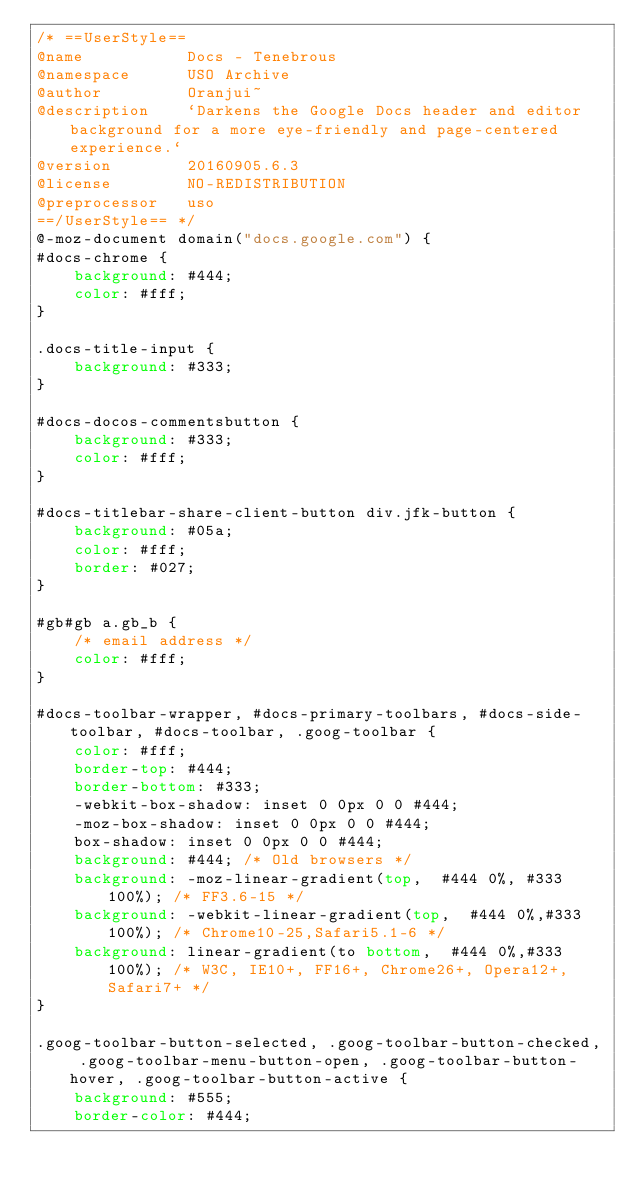Convert code to text. <code><loc_0><loc_0><loc_500><loc_500><_CSS_>/* ==UserStyle==
@name           Docs - Tenebrous
@namespace      USO Archive
@author         Oranjui~
@description    `Darkens the Google Docs header and editor background for a more eye-friendly and page-centered experience.`
@version        20160905.6.3
@license        NO-REDISTRIBUTION
@preprocessor   uso
==/UserStyle== */
@-moz-document domain("docs.google.com") {
#docs-chrome {
    background: #444;
    color: #fff;
}

.docs-title-input {
    background: #333;
}

#docs-docos-commentsbutton {
    background: #333;
    color: #fff;
}

#docs-titlebar-share-client-button div.jfk-button {
    background: #05a;
    color: #fff;
    border: #027;
}

#gb#gb a.gb_b {
    /* email address */
    color: #fff;
}

#docs-toolbar-wrapper, #docs-primary-toolbars, #docs-side-toolbar, #docs-toolbar, .goog-toolbar {
    color: #fff;
    border-top: #444;
    border-bottom: #333;
    -webkit-box-shadow: inset 0 0px 0 0 #444;
    -moz-box-shadow: inset 0 0px 0 0 #444;
    box-shadow: inset 0 0px 0 0 #444;
	background: #444; /* Old browsers */
	background: -moz-linear-gradient(top,  #444 0%, #333 100%); /* FF3.6-15 */
	background: -webkit-linear-gradient(top,  #444 0%,#333 100%); /* Chrome10-25,Safari5.1-6 */
	background: linear-gradient(to bottom,  #444 0%,#333 100%); /* W3C, IE10+, FF16+, Chrome26+, Opera12+, Safari7+ */
}

.goog-toolbar-button-selected, .goog-toolbar-button-checked, .goog-toolbar-menu-button-open, .goog-toolbar-button-hover, .goog-toolbar-button-active {
    background: #555;
    border-color: #444;</code> 